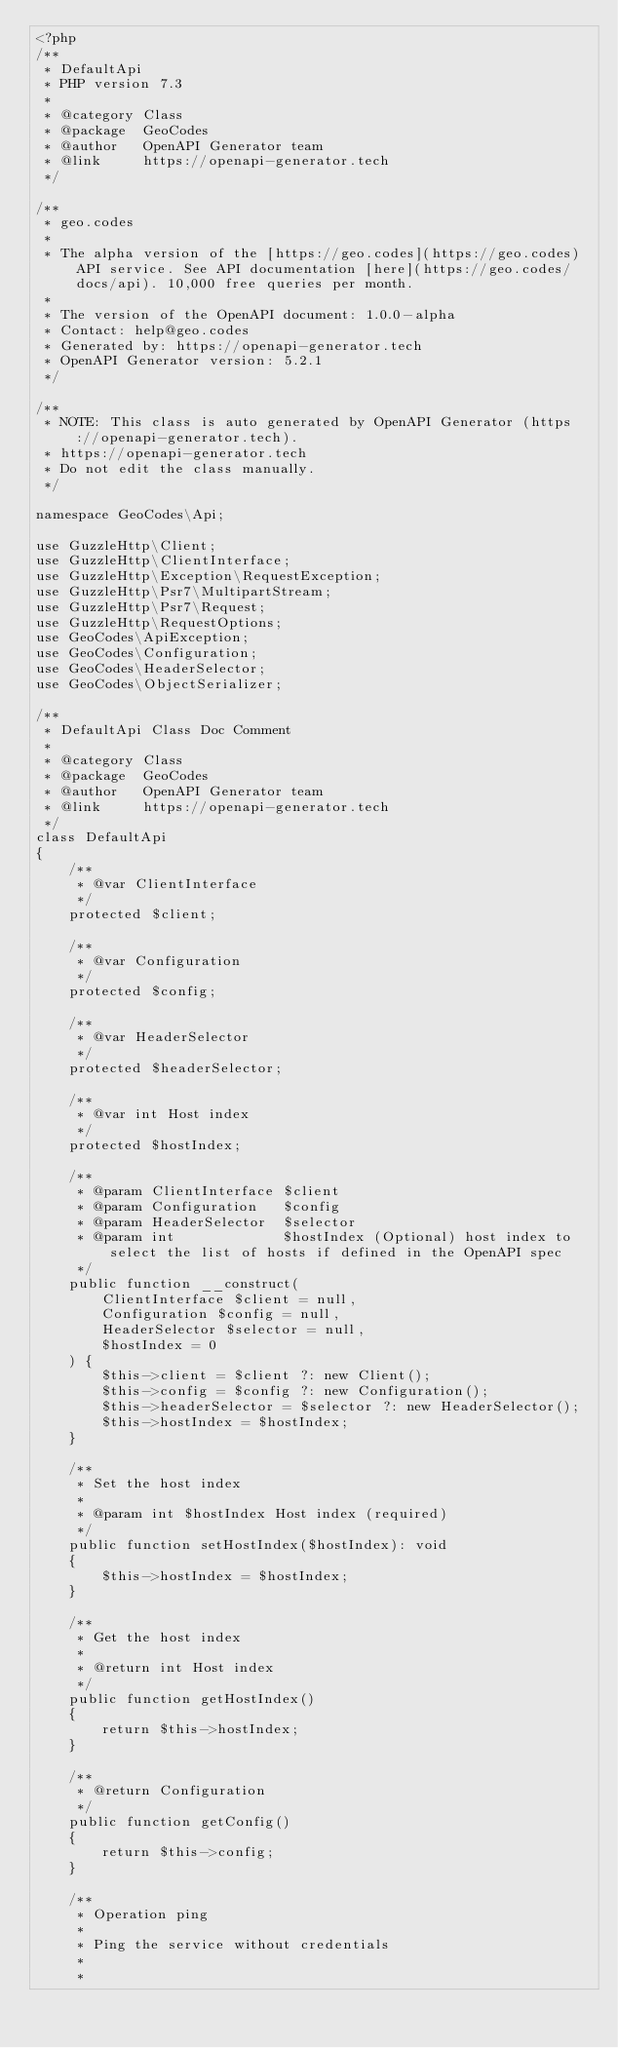Convert code to text. <code><loc_0><loc_0><loc_500><loc_500><_PHP_><?php
/**
 * DefaultApi
 * PHP version 7.3
 *
 * @category Class
 * @package  GeoCodes
 * @author   OpenAPI Generator team
 * @link     https://openapi-generator.tech
 */

/**
 * geo.codes
 *
 * The alpha version of the [https://geo.codes](https://geo.codes) API service. See API documentation [here](https://geo.codes/docs/api). 10,000 free queries per month.
 *
 * The version of the OpenAPI document: 1.0.0-alpha
 * Contact: help@geo.codes
 * Generated by: https://openapi-generator.tech
 * OpenAPI Generator version: 5.2.1
 */

/**
 * NOTE: This class is auto generated by OpenAPI Generator (https://openapi-generator.tech).
 * https://openapi-generator.tech
 * Do not edit the class manually.
 */

namespace GeoCodes\Api;

use GuzzleHttp\Client;
use GuzzleHttp\ClientInterface;
use GuzzleHttp\Exception\RequestException;
use GuzzleHttp\Psr7\MultipartStream;
use GuzzleHttp\Psr7\Request;
use GuzzleHttp\RequestOptions;
use GeoCodes\ApiException;
use GeoCodes\Configuration;
use GeoCodes\HeaderSelector;
use GeoCodes\ObjectSerializer;

/**
 * DefaultApi Class Doc Comment
 *
 * @category Class
 * @package  GeoCodes
 * @author   OpenAPI Generator team
 * @link     https://openapi-generator.tech
 */
class DefaultApi
{
    /**
     * @var ClientInterface
     */
    protected $client;

    /**
     * @var Configuration
     */
    protected $config;

    /**
     * @var HeaderSelector
     */
    protected $headerSelector;

    /**
     * @var int Host index
     */
    protected $hostIndex;

    /**
     * @param ClientInterface $client
     * @param Configuration   $config
     * @param HeaderSelector  $selector
     * @param int             $hostIndex (Optional) host index to select the list of hosts if defined in the OpenAPI spec
     */
    public function __construct(
        ClientInterface $client = null,
        Configuration $config = null,
        HeaderSelector $selector = null,
        $hostIndex = 0
    ) {
        $this->client = $client ?: new Client();
        $this->config = $config ?: new Configuration();
        $this->headerSelector = $selector ?: new HeaderSelector();
        $this->hostIndex = $hostIndex;
    }

    /**
     * Set the host index
     *
     * @param int $hostIndex Host index (required)
     */
    public function setHostIndex($hostIndex): void
    {
        $this->hostIndex = $hostIndex;
    }

    /**
     * Get the host index
     *
     * @return int Host index
     */
    public function getHostIndex()
    {
        return $this->hostIndex;
    }

    /**
     * @return Configuration
     */
    public function getConfig()
    {
        return $this->config;
    }

    /**
     * Operation ping
     *
     * Ping the service without credentials
     *
     *</code> 